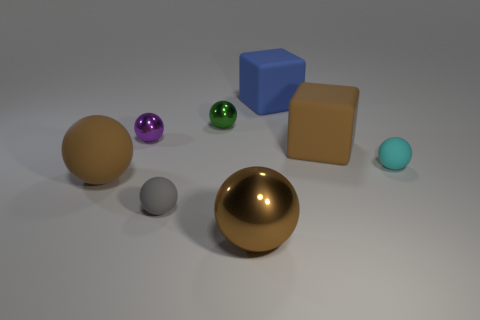If this were a still life painting, what emotions or themes do you think the artist might be trying to convey? If this image were a still life painting, the artist might be exploring themes of harmony and contrast through the use of varied colors and shapes. The different surfaces and reflections could symbolize diversity among unity, as each object maintains its unique qualities while coexisting peacefully. The simplicity of the scene might also suggest a sense of calm or contemplation, inviting the viewer to reflect on the interplay of light and texture. 